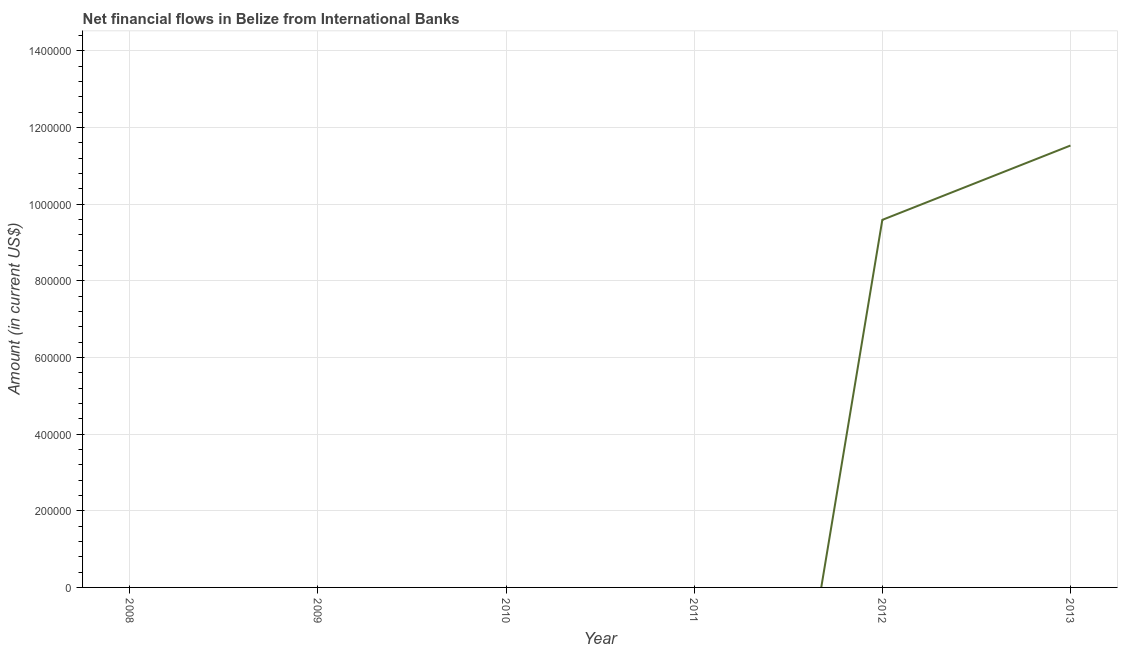What is the net financial flows from ibrd in 2010?
Make the answer very short. 0. Across all years, what is the maximum net financial flows from ibrd?
Offer a terse response. 1.15e+06. What is the sum of the net financial flows from ibrd?
Ensure brevity in your answer.  2.11e+06. What is the average net financial flows from ibrd per year?
Your response must be concise. 3.52e+05. In how many years, is the net financial flows from ibrd greater than 120000 US$?
Offer a very short reply. 2. What is the ratio of the net financial flows from ibrd in 2012 to that in 2013?
Your answer should be compact. 0.83. What is the difference between the highest and the lowest net financial flows from ibrd?
Your answer should be very brief. 1.15e+06. In how many years, is the net financial flows from ibrd greater than the average net financial flows from ibrd taken over all years?
Give a very brief answer. 2. Does the net financial flows from ibrd monotonically increase over the years?
Your response must be concise. Yes. How many lines are there?
Provide a short and direct response. 1. What is the difference between two consecutive major ticks on the Y-axis?
Make the answer very short. 2.00e+05. Are the values on the major ticks of Y-axis written in scientific E-notation?
Offer a terse response. No. What is the title of the graph?
Your answer should be very brief. Net financial flows in Belize from International Banks. What is the label or title of the Y-axis?
Your response must be concise. Amount (in current US$). What is the Amount (in current US$) of 2011?
Provide a succinct answer. 0. What is the Amount (in current US$) in 2012?
Offer a very short reply. 9.59e+05. What is the Amount (in current US$) of 2013?
Keep it short and to the point. 1.15e+06. What is the difference between the Amount (in current US$) in 2012 and 2013?
Keep it short and to the point. -1.94e+05. What is the ratio of the Amount (in current US$) in 2012 to that in 2013?
Provide a succinct answer. 0.83. 